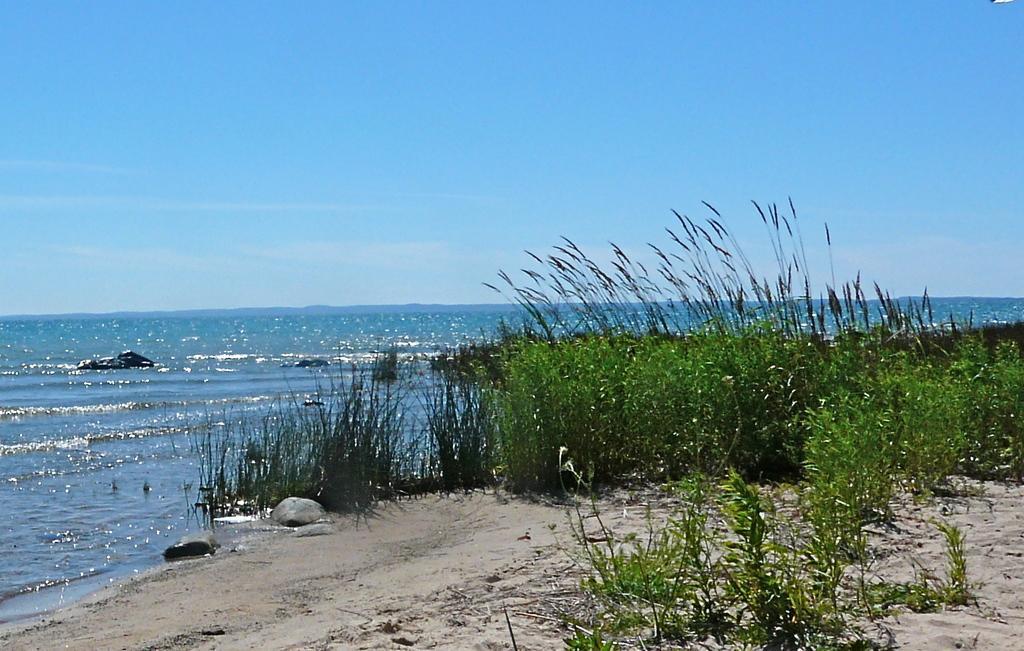Can you describe this image briefly? In this image at the bottom there are some plants and sand, in the background there is a beach. On the top of the image there is sky. 